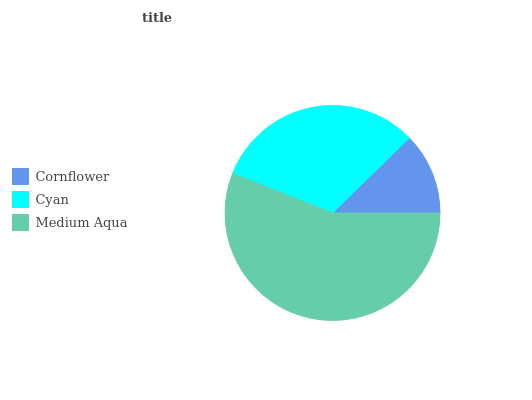Is Cornflower the minimum?
Answer yes or no. Yes. Is Medium Aqua the maximum?
Answer yes or no. Yes. Is Cyan the minimum?
Answer yes or no. No. Is Cyan the maximum?
Answer yes or no. No. Is Cyan greater than Cornflower?
Answer yes or no. Yes. Is Cornflower less than Cyan?
Answer yes or no. Yes. Is Cornflower greater than Cyan?
Answer yes or no. No. Is Cyan less than Cornflower?
Answer yes or no. No. Is Cyan the high median?
Answer yes or no. Yes. Is Cyan the low median?
Answer yes or no. Yes. Is Cornflower the high median?
Answer yes or no. No. Is Medium Aqua the low median?
Answer yes or no. No. 